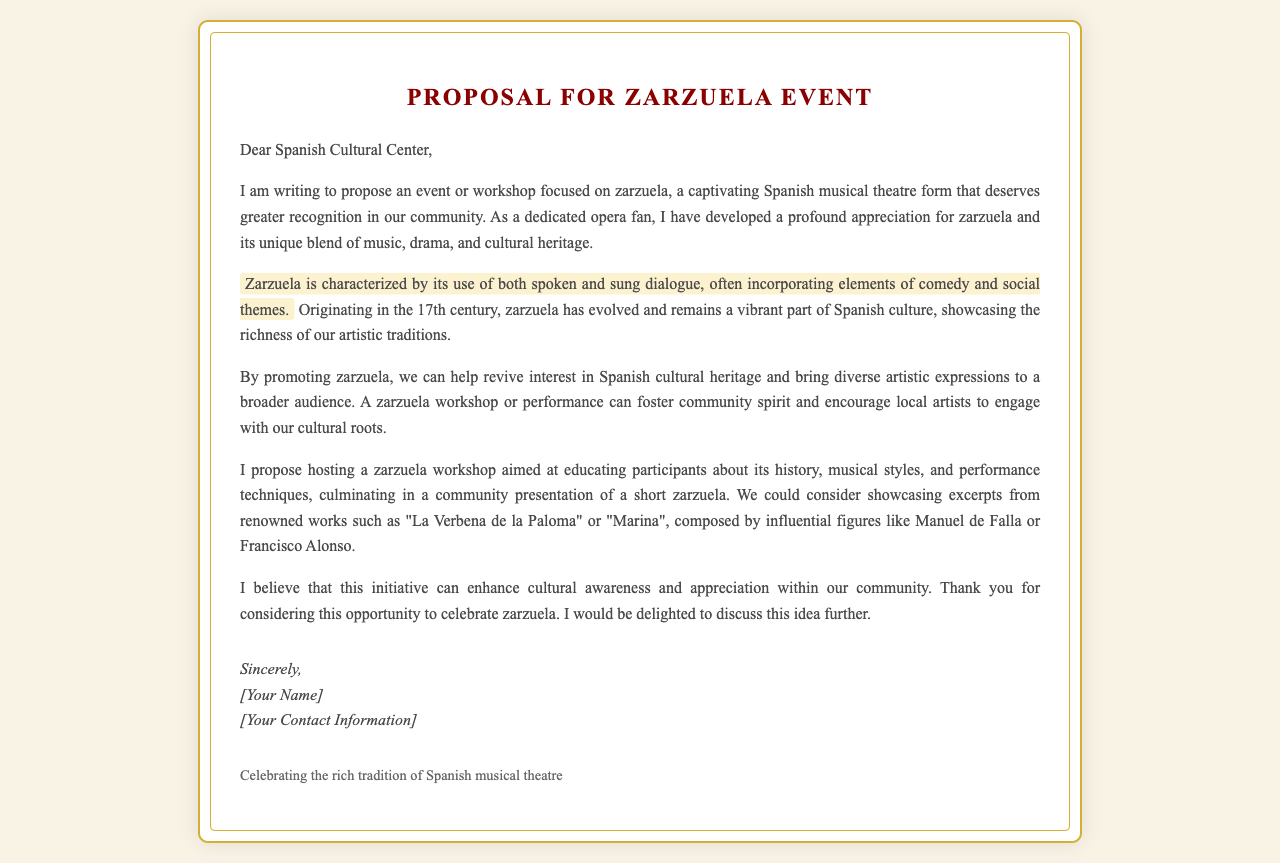What is the title of the proposal? The title of the proposal is clearly stated at the beginning of the document.
Answer: Proposal for Zarzuela Event Who is the letter addressed to? The recipient of the letter is mentioned right after the salutation.
Answer: Spanish Cultural Center What are the main themes of zarzuela mentioned? The letter describes characteristics of zarzuela, highlighting its unique elements.
Answer: Spoken and sung dialogue, comedy, social themes When did zarzuela originate? The document specifies the time period in which zarzuela began.
Answer: 17th century What is proposed to educate participants about zarzuela? The writer suggests a specific type of event aimed at sharing knowledge about zarzuela.
Answer: Workshop Which two zarzuela works are mentioned in the proposal? The proposal lists examples of zarzuela works to be showcased.
Answer: La Verbena de la Paloma, Marina What is the purpose of promoting zarzuela according to the letter? The writer expresses the intended impact of promoting zarzuela within the community.
Answer: Revive interest in Spanish cultural heritage What can a zarzuela workshop foster in the community? The letter discusses the benefits of hosting a zarzuela related event.
Answer: Community spirit What does the writer hope to discuss further? The conclusion of the letter indicates the writer's desire to continue communication regarding the proposal.
Answer: This idea 